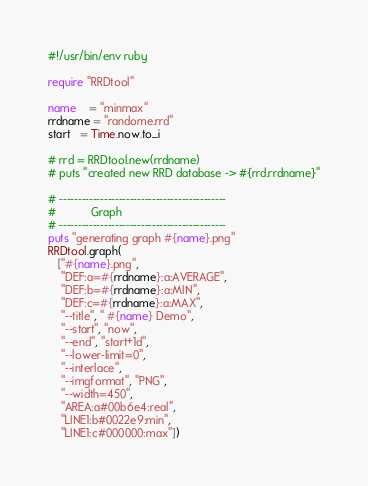Convert code to text. <code><loc_0><loc_0><loc_500><loc_500><_Ruby_>#!/usr/bin/env ruby

require "RRDtool"

name    = "minmax"
rrdname = "randome.rrd"
start   = Time.now.to_i

# rrd = RRDtool.new(rrdname)
# puts "created new RRD database -> #{rrd.rrdname}"

# ---------------------------------------------
#           Graph
# ---------------------------------------------
puts "generating graph #{name}.png"
RRDtool.graph(
   ["#{name}.png",
    "DEF:a=#{rrdname}:a:AVERAGE",
    "DEF:b=#{rrdname}:a:MIN",
    "DEF:c=#{rrdname}:a:MAX",
    "--title", " #{name} Demo", 
    "--start", "now",
    "--end", "start+1d",
    "--lower-limit=0",
    "--interlace",
    "--imgformat", "PNG",
    "--width=450",
    "AREA:a#00b6e4:real",
    "LINE1:b#0022e9:min",
    "LINE1:c#000000:max"])
</code> 